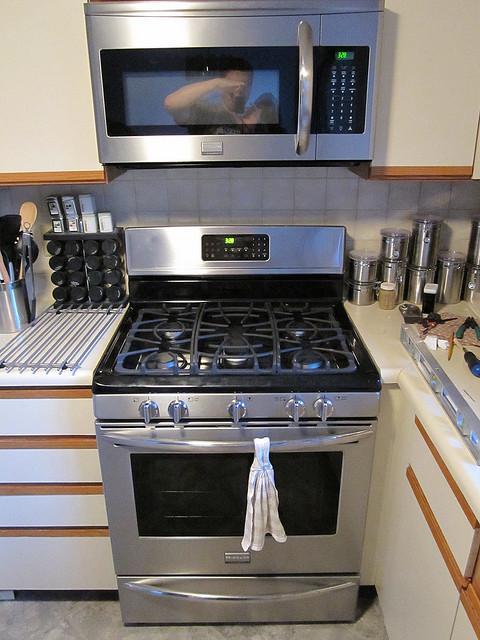How many clocks do you see?
Give a very brief answer. 0. 